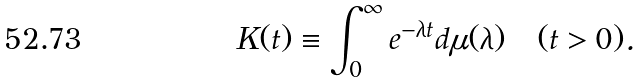Convert formula to latex. <formula><loc_0><loc_0><loc_500><loc_500>K ( t ) \equiv \int ^ { \infty } _ { 0 } e ^ { - \lambda t } d \mu ( \lambda ) \quad ( t > 0 ) .</formula> 